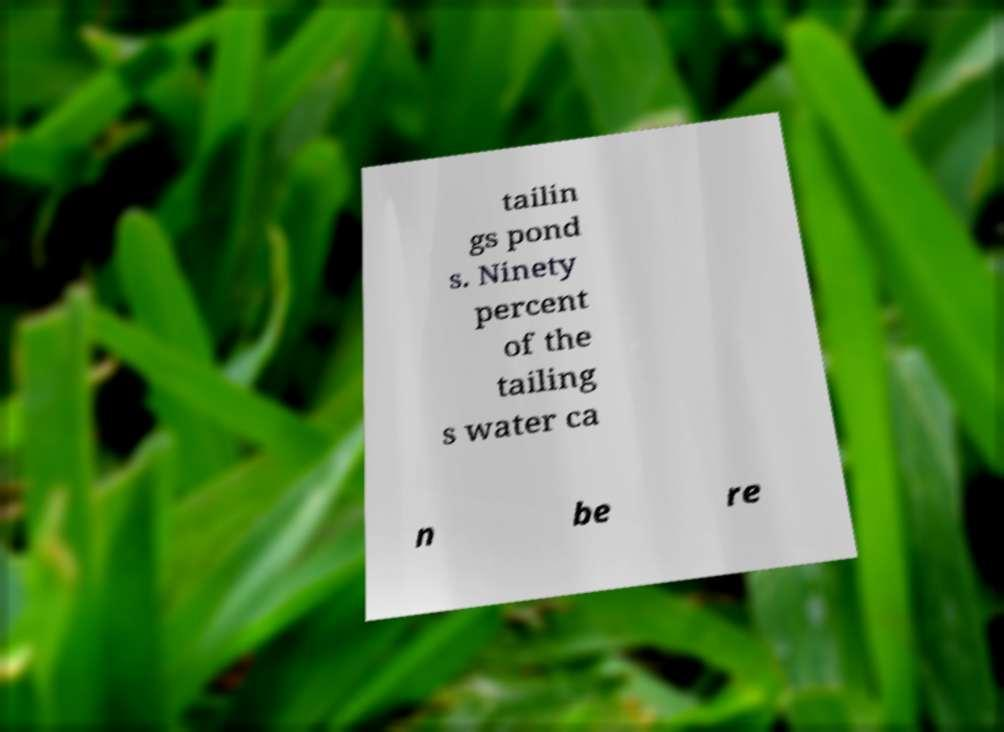There's text embedded in this image that I need extracted. Can you transcribe it verbatim? tailin gs pond s. Ninety percent of the tailing s water ca n be re 